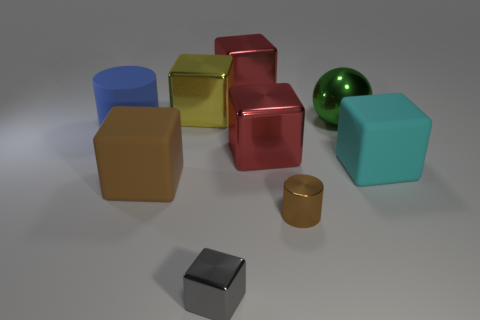Subtract all red blocks. How many were subtracted if there are1red blocks left? 1 Subtract all big brown matte cubes. How many cubes are left? 5 Subtract all yellow cubes. How many cubes are left? 5 Subtract 1 spheres. How many spheres are left? 0 Subtract all blocks. How many objects are left? 3 Subtract all brown cylinders. How many red cubes are left? 2 Add 2 cyan cubes. How many cyan cubes are left? 3 Add 8 cyan objects. How many cyan objects exist? 9 Subtract 0 purple blocks. How many objects are left? 9 Subtract all gray blocks. Subtract all gray balls. How many blocks are left? 5 